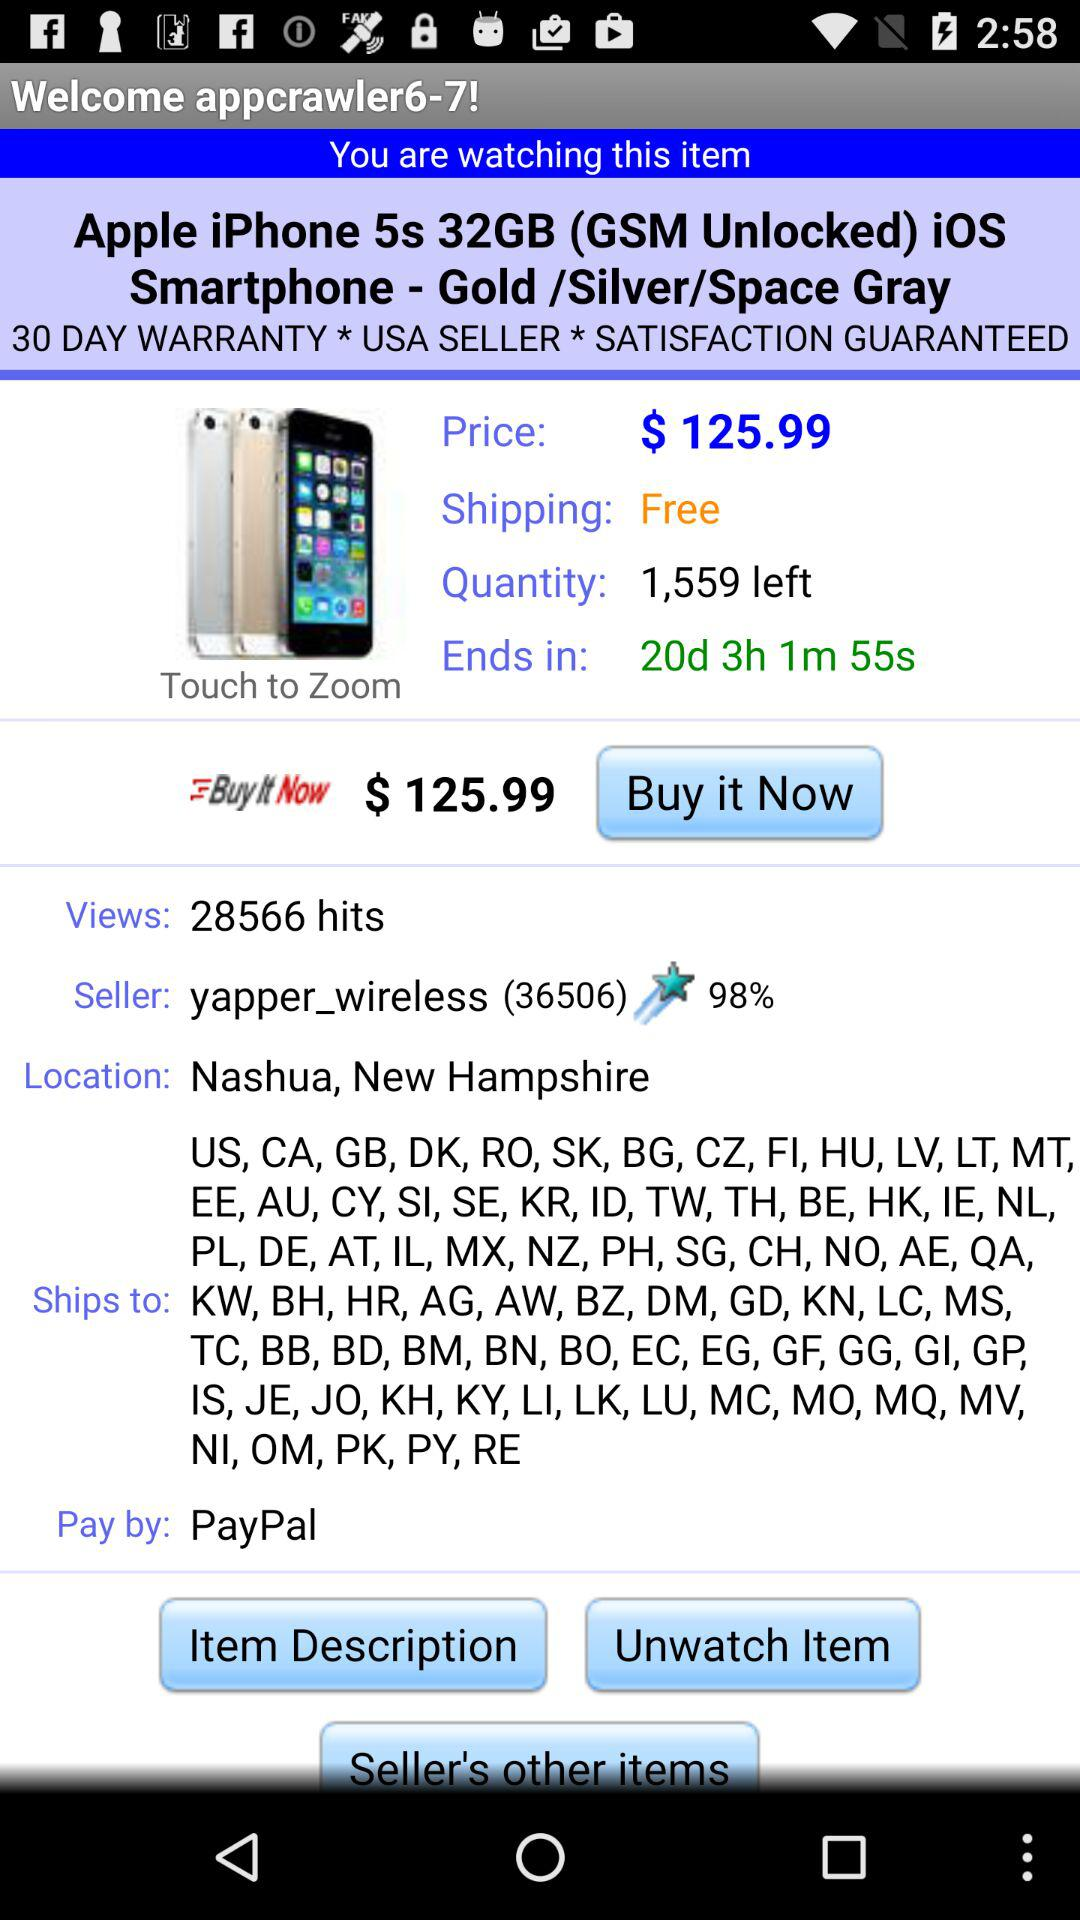How much is the item shipping?
Answer the question using a single word or phrase. Free 